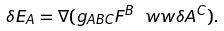Convert formula to latex. <formula><loc_0><loc_0><loc_500><loc_500>\delta E _ { A } = \nabla ( g _ { A B C } F ^ { B } \ w w \delta A ^ { C } ) .</formula> 